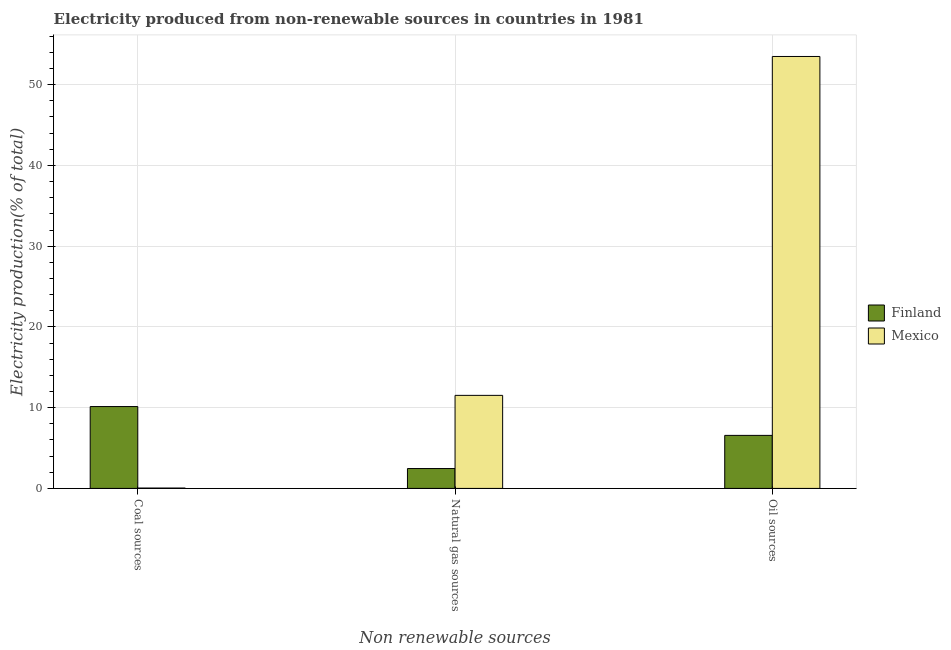How many different coloured bars are there?
Give a very brief answer. 2. How many groups of bars are there?
Give a very brief answer. 3. Are the number of bars per tick equal to the number of legend labels?
Offer a very short reply. Yes. Are the number of bars on each tick of the X-axis equal?
Your answer should be compact. Yes. How many bars are there on the 1st tick from the right?
Offer a very short reply. 2. What is the label of the 1st group of bars from the left?
Your answer should be compact. Coal sources. What is the percentage of electricity produced by coal in Mexico?
Keep it short and to the point. 0.05. Across all countries, what is the maximum percentage of electricity produced by oil sources?
Ensure brevity in your answer.  53.49. Across all countries, what is the minimum percentage of electricity produced by oil sources?
Offer a terse response. 6.57. In which country was the percentage of electricity produced by coal maximum?
Give a very brief answer. Finland. In which country was the percentage of electricity produced by natural gas minimum?
Your answer should be compact. Finland. What is the total percentage of electricity produced by coal in the graph?
Provide a succinct answer. 10.18. What is the difference between the percentage of electricity produced by oil sources in Finland and that in Mexico?
Ensure brevity in your answer.  -46.92. What is the difference between the percentage of electricity produced by oil sources in Finland and the percentage of electricity produced by natural gas in Mexico?
Make the answer very short. -4.95. What is the average percentage of electricity produced by coal per country?
Keep it short and to the point. 5.09. What is the difference between the percentage of electricity produced by natural gas and percentage of electricity produced by coal in Finland?
Provide a succinct answer. -7.68. What is the ratio of the percentage of electricity produced by natural gas in Mexico to that in Finland?
Your answer should be compact. 4.68. What is the difference between the highest and the second highest percentage of electricity produced by natural gas?
Offer a terse response. 9.06. What is the difference between the highest and the lowest percentage of electricity produced by natural gas?
Your answer should be compact. 9.06. In how many countries, is the percentage of electricity produced by coal greater than the average percentage of electricity produced by coal taken over all countries?
Make the answer very short. 1. Is the sum of the percentage of electricity produced by natural gas in Finland and Mexico greater than the maximum percentage of electricity produced by oil sources across all countries?
Make the answer very short. No. What does the 2nd bar from the left in Oil sources represents?
Your answer should be compact. Mexico. What does the 2nd bar from the right in Oil sources represents?
Your answer should be very brief. Finland. How many bars are there?
Make the answer very short. 6. How many countries are there in the graph?
Offer a very short reply. 2. What is the difference between two consecutive major ticks on the Y-axis?
Offer a terse response. 10. Does the graph contain any zero values?
Offer a very short reply. No. How are the legend labels stacked?
Offer a terse response. Vertical. What is the title of the graph?
Your response must be concise. Electricity produced from non-renewable sources in countries in 1981. Does "Samoa" appear as one of the legend labels in the graph?
Keep it short and to the point. No. What is the label or title of the X-axis?
Offer a terse response. Non renewable sources. What is the label or title of the Y-axis?
Your answer should be very brief. Electricity production(% of total). What is the Electricity production(% of total) of Finland in Coal sources?
Ensure brevity in your answer.  10.14. What is the Electricity production(% of total) of Mexico in Coal sources?
Keep it short and to the point. 0.05. What is the Electricity production(% of total) in Finland in Natural gas sources?
Provide a short and direct response. 2.46. What is the Electricity production(% of total) of Mexico in Natural gas sources?
Offer a very short reply. 11.52. What is the Electricity production(% of total) in Finland in Oil sources?
Your answer should be compact. 6.57. What is the Electricity production(% of total) of Mexico in Oil sources?
Your answer should be compact. 53.49. Across all Non renewable sources, what is the maximum Electricity production(% of total) in Finland?
Make the answer very short. 10.14. Across all Non renewable sources, what is the maximum Electricity production(% of total) in Mexico?
Your answer should be very brief. 53.49. Across all Non renewable sources, what is the minimum Electricity production(% of total) of Finland?
Give a very brief answer. 2.46. Across all Non renewable sources, what is the minimum Electricity production(% of total) of Mexico?
Offer a very short reply. 0.05. What is the total Electricity production(% of total) in Finland in the graph?
Your answer should be compact. 19.17. What is the total Electricity production(% of total) of Mexico in the graph?
Provide a short and direct response. 65.06. What is the difference between the Electricity production(% of total) of Finland in Coal sources and that in Natural gas sources?
Your answer should be very brief. 7.68. What is the difference between the Electricity production(% of total) in Mexico in Coal sources and that in Natural gas sources?
Your answer should be compact. -11.48. What is the difference between the Electricity production(% of total) of Finland in Coal sources and that in Oil sources?
Provide a succinct answer. 3.57. What is the difference between the Electricity production(% of total) in Mexico in Coal sources and that in Oil sources?
Your response must be concise. -53.45. What is the difference between the Electricity production(% of total) in Finland in Natural gas sources and that in Oil sources?
Make the answer very short. -4.11. What is the difference between the Electricity production(% of total) of Mexico in Natural gas sources and that in Oil sources?
Offer a very short reply. -41.97. What is the difference between the Electricity production(% of total) in Finland in Coal sources and the Electricity production(% of total) in Mexico in Natural gas sources?
Provide a succinct answer. -1.39. What is the difference between the Electricity production(% of total) in Finland in Coal sources and the Electricity production(% of total) in Mexico in Oil sources?
Your response must be concise. -43.35. What is the difference between the Electricity production(% of total) of Finland in Natural gas sources and the Electricity production(% of total) of Mexico in Oil sources?
Make the answer very short. -51.03. What is the average Electricity production(% of total) of Finland per Non renewable sources?
Offer a very short reply. 6.39. What is the average Electricity production(% of total) in Mexico per Non renewable sources?
Provide a succinct answer. 21.69. What is the difference between the Electricity production(% of total) in Finland and Electricity production(% of total) in Mexico in Coal sources?
Your answer should be compact. 10.09. What is the difference between the Electricity production(% of total) in Finland and Electricity production(% of total) in Mexico in Natural gas sources?
Provide a succinct answer. -9.06. What is the difference between the Electricity production(% of total) of Finland and Electricity production(% of total) of Mexico in Oil sources?
Your response must be concise. -46.92. What is the ratio of the Electricity production(% of total) of Finland in Coal sources to that in Natural gas sources?
Give a very brief answer. 4.12. What is the ratio of the Electricity production(% of total) in Mexico in Coal sources to that in Natural gas sources?
Give a very brief answer. 0. What is the ratio of the Electricity production(% of total) of Finland in Coal sources to that in Oil sources?
Ensure brevity in your answer.  1.54. What is the ratio of the Electricity production(% of total) of Mexico in Coal sources to that in Oil sources?
Give a very brief answer. 0. What is the ratio of the Electricity production(% of total) of Finland in Natural gas sources to that in Oil sources?
Your response must be concise. 0.37. What is the ratio of the Electricity production(% of total) in Mexico in Natural gas sources to that in Oil sources?
Your answer should be compact. 0.22. What is the difference between the highest and the second highest Electricity production(% of total) in Finland?
Give a very brief answer. 3.57. What is the difference between the highest and the second highest Electricity production(% of total) in Mexico?
Your answer should be very brief. 41.97. What is the difference between the highest and the lowest Electricity production(% of total) in Finland?
Provide a succinct answer. 7.68. What is the difference between the highest and the lowest Electricity production(% of total) of Mexico?
Offer a very short reply. 53.45. 